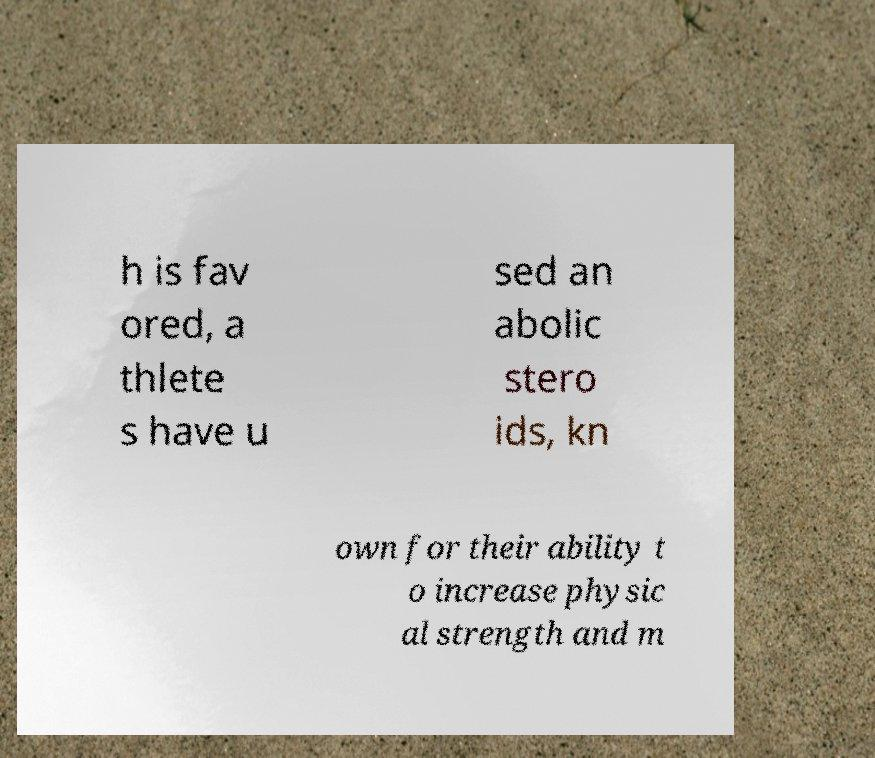What messages or text are displayed in this image? I need them in a readable, typed format. h is fav ored, a thlete s have u sed an abolic stero ids, kn own for their ability t o increase physic al strength and m 